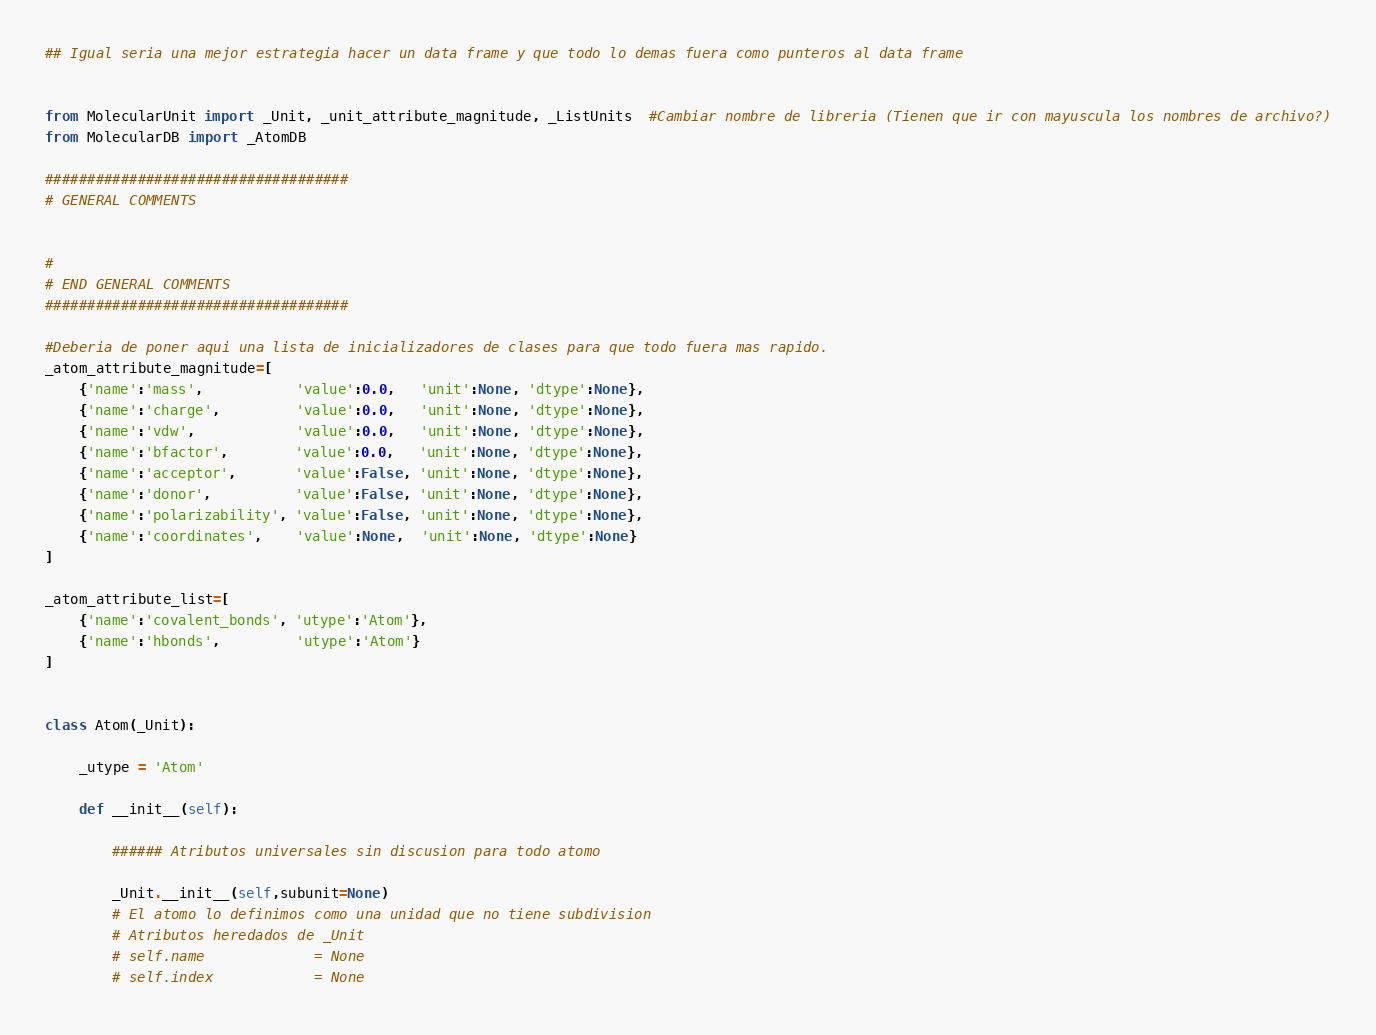<code> <loc_0><loc_0><loc_500><loc_500><_Python_>## Igual seria una mejor estrategia hacer un data frame y que todo lo demas fuera como punteros al data frame


from MolecularUnit import _Unit, _unit_attribute_magnitude, _ListUnits  #Cambiar nombre de libreria (Tienen que ir con mayuscula los nombres de archivo?)
from MolecularDB import _AtomDB

####################################
# GENERAL COMMENTS


#
# END GENERAL COMMENTS
####################################

#Deberia de poner aqui una lista de inicializadores de clases para que todo fuera mas rapido. 
_atom_attribute_magnitude=[
    {'name':'mass',           'value':0.0,   'unit':None, 'dtype':None},
    {'name':'charge',         'value':0.0,   'unit':None, 'dtype':None},
    {'name':'vdw',            'value':0.0,   'unit':None, 'dtype':None},
    {'name':'bfactor',        'value':0.0,   'unit':None, 'dtype':None},
    {'name':'acceptor',       'value':False, 'unit':None, 'dtype':None},
    {'name':'donor',          'value':False, 'unit':None, 'dtype':None},
    {'name':'polarizability', 'value':False, 'unit':None, 'dtype':None},
    {'name':'coordinates',    'value':None,  'unit':None, 'dtype':None}
]

_atom_attribute_list=[
    {'name':'covalent_bonds', 'utype':'Atom'},
    {'name':'hbonds',         'utype':'Atom'}
]


class Atom(_Unit):

    _utype = 'Atom'

    def __init__(self):
     
        ###### Atributos universales sin discusion para todo atomo
        
        _Unit.__init__(self,subunit=None)
        # El atomo lo definimos como una unidad que no tiene subdivision
        # Atributos heredados de _Unit
        # self.name             = None
        # self.index            = None</code> 